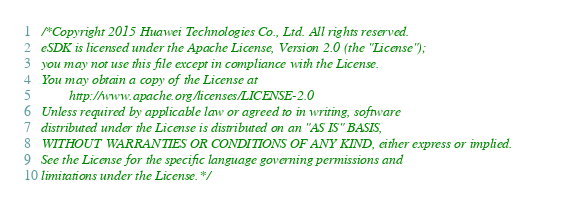Convert code to text. <code><loc_0><loc_0><loc_500><loc_500><_C_>/*Copyright 2015 Huawei Technologies Co., Ltd. All rights reserved.
eSDK is licensed under the Apache License, Version 2.0 (the "License");
you may not use this file except in compliance with the License.
You may obtain a copy of the License at
		http://www.apache.org/licenses/LICENSE-2.0
Unless required by applicable law or agreed to in writing, software
distributed under the License is distributed on an "AS IS" BASIS,
WITHOUT WARRANTIES OR CONDITIONS OF ANY KIND, either express or implied.
See the License for the specific language governing permissions and
limitations under the License.*/

</code> 